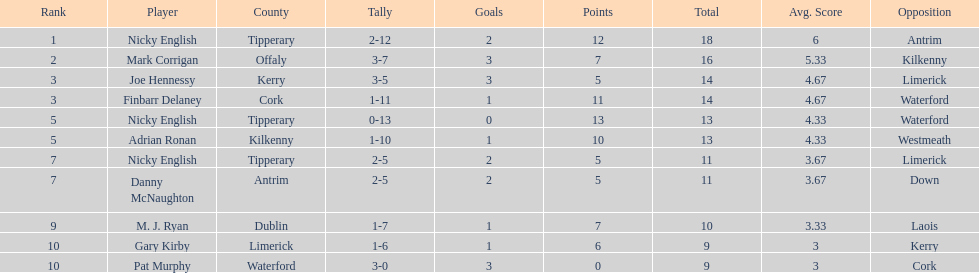What is the first name on the list? Nicky English. 